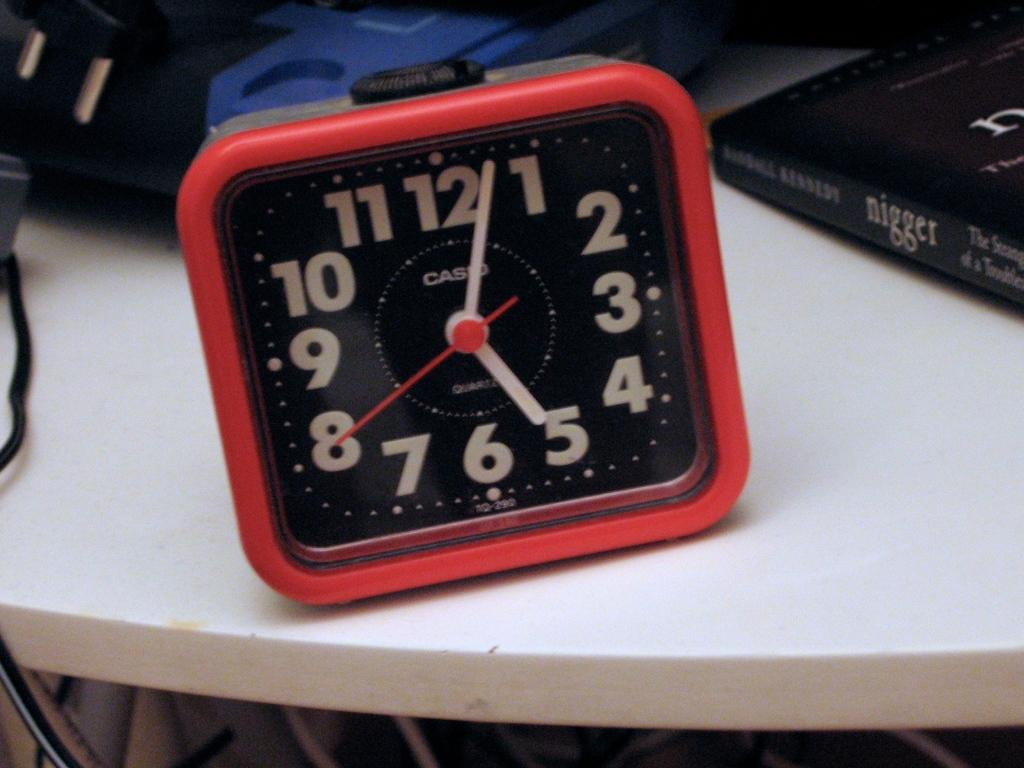Provide a one-sentence caption for the provided image. A red Casio clock sits on a table next to an offensive titled book. 